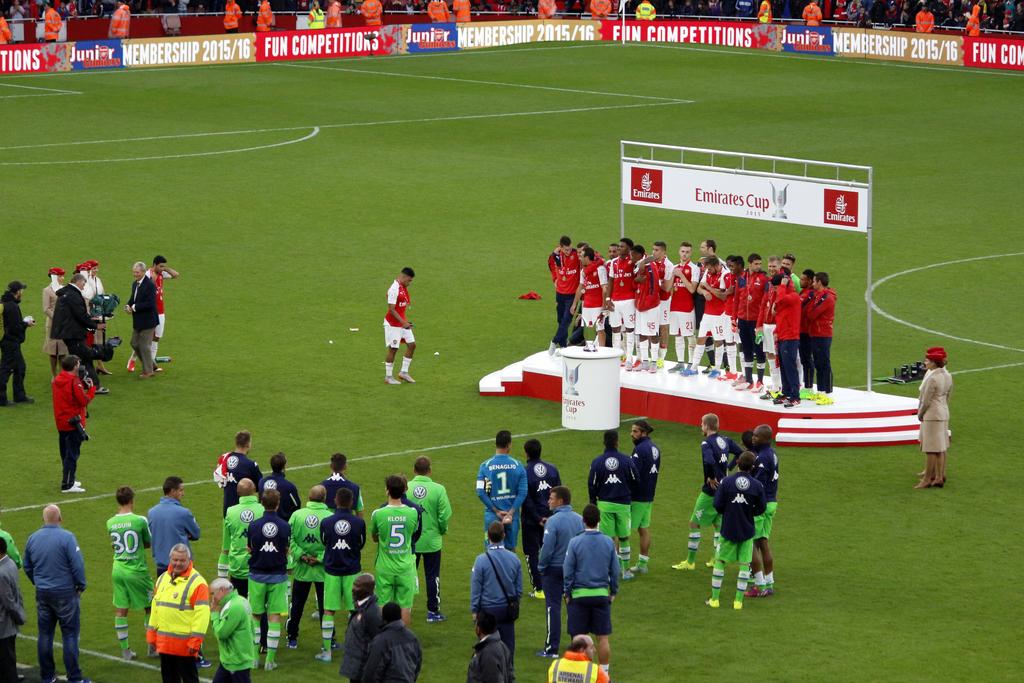What cup is being won?
Offer a terse response. Emirates cup. What nation is having this cup?
Provide a succinct answer. Emirates. 